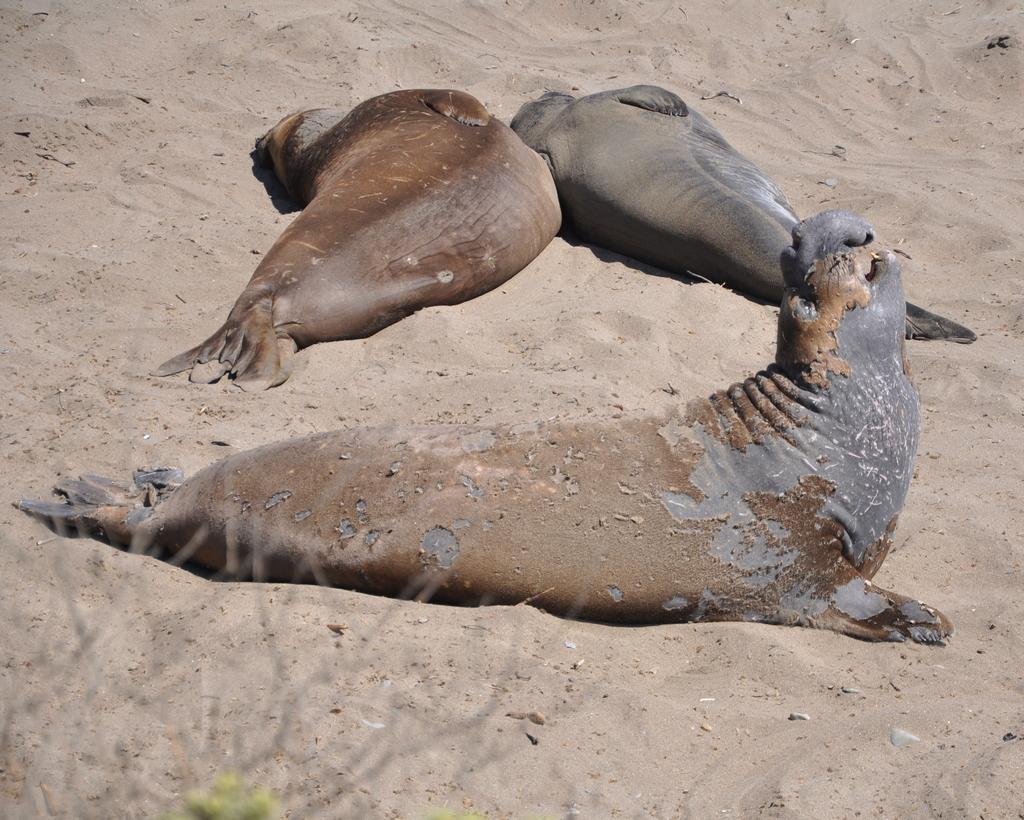Can you describe this image briefly? In this picture, we see three elephant seals. At the bottom of the picture, we see the plants and sand. 